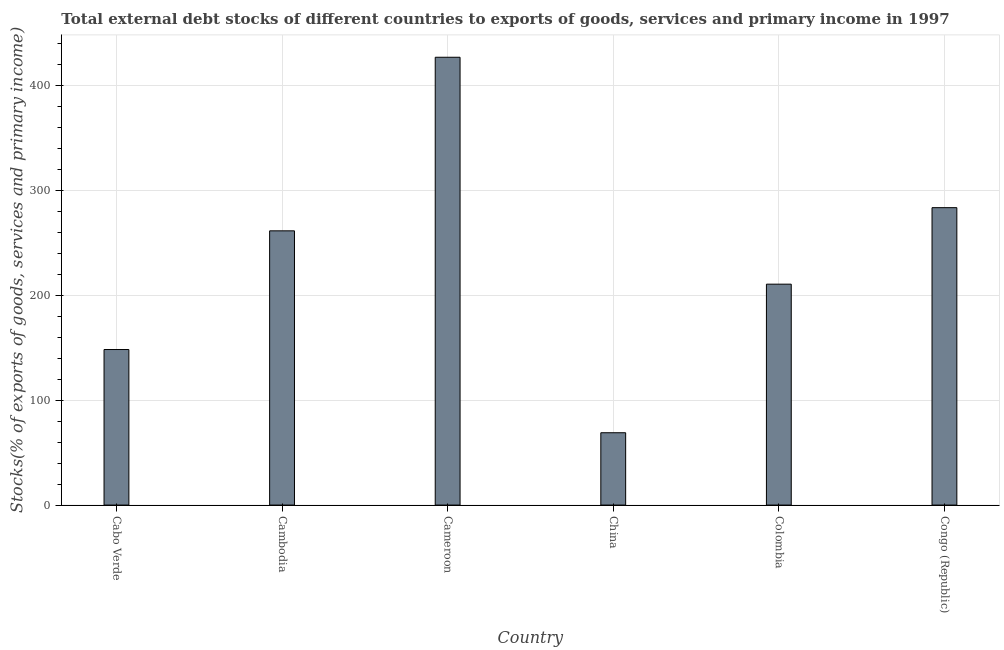Does the graph contain grids?
Keep it short and to the point. Yes. What is the title of the graph?
Provide a short and direct response. Total external debt stocks of different countries to exports of goods, services and primary income in 1997. What is the label or title of the X-axis?
Keep it short and to the point. Country. What is the label or title of the Y-axis?
Provide a short and direct response. Stocks(% of exports of goods, services and primary income). What is the external debt stocks in Colombia?
Keep it short and to the point. 210.38. Across all countries, what is the maximum external debt stocks?
Ensure brevity in your answer.  426.46. Across all countries, what is the minimum external debt stocks?
Offer a terse response. 68.89. In which country was the external debt stocks maximum?
Your answer should be compact. Cameroon. In which country was the external debt stocks minimum?
Offer a very short reply. China. What is the sum of the external debt stocks?
Provide a short and direct response. 1398.27. What is the difference between the external debt stocks in Cabo Verde and Colombia?
Your answer should be very brief. -62.25. What is the average external debt stocks per country?
Give a very brief answer. 233.04. What is the median external debt stocks?
Provide a succinct answer. 235.77. In how many countries, is the external debt stocks greater than 20 %?
Your answer should be compact. 6. What is the ratio of the external debt stocks in Cabo Verde to that in Congo (Republic)?
Your answer should be compact. 0.52. Is the external debt stocks in China less than that in Colombia?
Keep it short and to the point. Yes. What is the difference between the highest and the second highest external debt stocks?
Give a very brief answer. 143.23. What is the difference between the highest and the lowest external debt stocks?
Provide a short and direct response. 357.58. In how many countries, is the external debt stocks greater than the average external debt stocks taken over all countries?
Keep it short and to the point. 3. How many bars are there?
Offer a terse response. 6. Are all the bars in the graph horizontal?
Your response must be concise. No. How many countries are there in the graph?
Ensure brevity in your answer.  6. Are the values on the major ticks of Y-axis written in scientific E-notation?
Keep it short and to the point. No. What is the Stocks(% of exports of goods, services and primary income) of Cabo Verde?
Offer a very short reply. 148.14. What is the Stocks(% of exports of goods, services and primary income) of Cambodia?
Offer a terse response. 261.16. What is the Stocks(% of exports of goods, services and primary income) of Cameroon?
Your response must be concise. 426.46. What is the Stocks(% of exports of goods, services and primary income) of China?
Ensure brevity in your answer.  68.89. What is the Stocks(% of exports of goods, services and primary income) of Colombia?
Your response must be concise. 210.38. What is the Stocks(% of exports of goods, services and primary income) in Congo (Republic)?
Your response must be concise. 283.23. What is the difference between the Stocks(% of exports of goods, services and primary income) in Cabo Verde and Cambodia?
Offer a terse response. -113.03. What is the difference between the Stocks(% of exports of goods, services and primary income) in Cabo Verde and Cameroon?
Your response must be concise. -278.33. What is the difference between the Stocks(% of exports of goods, services and primary income) in Cabo Verde and China?
Keep it short and to the point. 79.25. What is the difference between the Stocks(% of exports of goods, services and primary income) in Cabo Verde and Colombia?
Ensure brevity in your answer.  -62.25. What is the difference between the Stocks(% of exports of goods, services and primary income) in Cabo Verde and Congo (Republic)?
Your answer should be very brief. -135.1. What is the difference between the Stocks(% of exports of goods, services and primary income) in Cambodia and Cameroon?
Your answer should be compact. -165.3. What is the difference between the Stocks(% of exports of goods, services and primary income) in Cambodia and China?
Your answer should be very brief. 192.27. What is the difference between the Stocks(% of exports of goods, services and primary income) in Cambodia and Colombia?
Keep it short and to the point. 50.78. What is the difference between the Stocks(% of exports of goods, services and primary income) in Cambodia and Congo (Republic)?
Make the answer very short. -22.07. What is the difference between the Stocks(% of exports of goods, services and primary income) in Cameroon and China?
Your answer should be compact. 357.58. What is the difference between the Stocks(% of exports of goods, services and primary income) in Cameroon and Colombia?
Keep it short and to the point. 216.08. What is the difference between the Stocks(% of exports of goods, services and primary income) in Cameroon and Congo (Republic)?
Ensure brevity in your answer.  143.23. What is the difference between the Stocks(% of exports of goods, services and primary income) in China and Colombia?
Provide a succinct answer. -141.49. What is the difference between the Stocks(% of exports of goods, services and primary income) in China and Congo (Republic)?
Offer a terse response. -214.35. What is the difference between the Stocks(% of exports of goods, services and primary income) in Colombia and Congo (Republic)?
Your response must be concise. -72.85. What is the ratio of the Stocks(% of exports of goods, services and primary income) in Cabo Verde to that in Cambodia?
Offer a very short reply. 0.57. What is the ratio of the Stocks(% of exports of goods, services and primary income) in Cabo Verde to that in Cameroon?
Your response must be concise. 0.35. What is the ratio of the Stocks(% of exports of goods, services and primary income) in Cabo Verde to that in China?
Make the answer very short. 2.15. What is the ratio of the Stocks(% of exports of goods, services and primary income) in Cabo Verde to that in Colombia?
Your answer should be very brief. 0.7. What is the ratio of the Stocks(% of exports of goods, services and primary income) in Cabo Verde to that in Congo (Republic)?
Provide a succinct answer. 0.52. What is the ratio of the Stocks(% of exports of goods, services and primary income) in Cambodia to that in Cameroon?
Offer a terse response. 0.61. What is the ratio of the Stocks(% of exports of goods, services and primary income) in Cambodia to that in China?
Your response must be concise. 3.79. What is the ratio of the Stocks(% of exports of goods, services and primary income) in Cambodia to that in Colombia?
Make the answer very short. 1.24. What is the ratio of the Stocks(% of exports of goods, services and primary income) in Cambodia to that in Congo (Republic)?
Provide a succinct answer. 0.92. What is the ratio of the Stocks(% of exports of goods, services and primary income) in Cameroon to that in China?
Your response must be concise. 6.19. What is the ratio of the Stocks(% of exports of goods, services and primary income) in Cameroon to that in Colombia?
Provide a short and direct response. 2.03. What is the ratio of the Stocks(% of exports of goods, services and primary income) in Cameroon to that in Congo (Republic)?
Your response must be concise. 1.51. What is the ratio of the Stocks(% of exports of goods, services and primary income) in China to that in Colombia?
Your response must be concise. 0.33. What is the ratio of the Stocks(% of exports of goods, services and primary income) in China to that in Congo (Republic)?
Make the answer very short. 0.24. What is the ratio of the Stocks(% of exports of goods, services and primary income) in Colombia to that in Congo (Republic)?
Offer a very short reply. 0.74. 